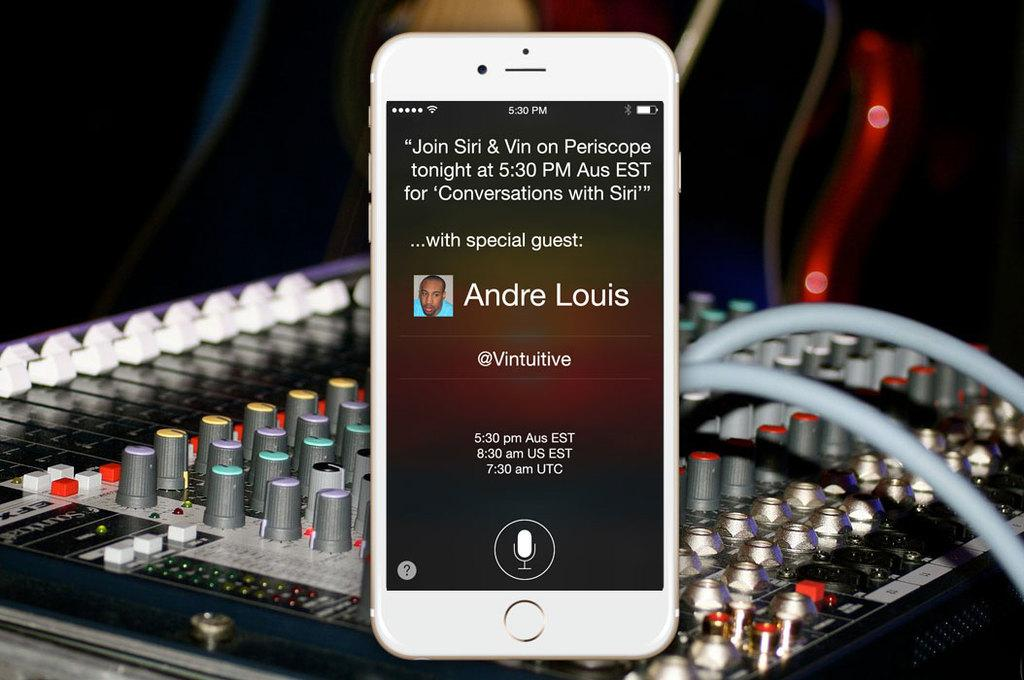Provide a one-sentence caption for the provided image. On the screen of an Iphone is a reminder for a Periscope show at 5:30 PM with special guest Andre Louis. 